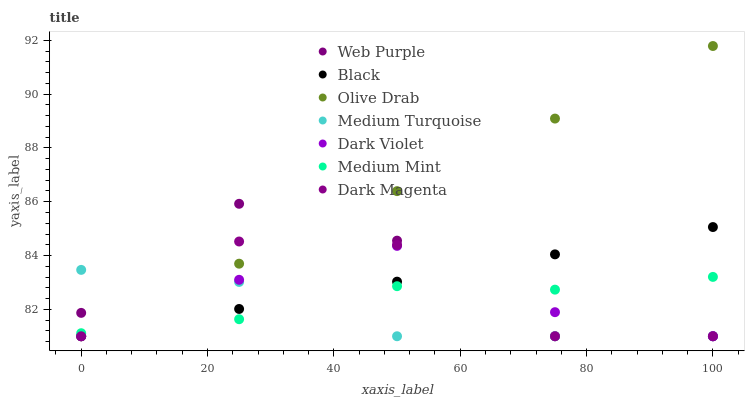Does Medium Turquoise have the minimum area under the curve?
Answer yes or no. Yes. Does Olive Drab have the maximum area under the curve?
Answer yes or no. Yes. Does Dark Magenta have the minimum area under the curve?
Answer yes or no. No. Does Dark Magenta have the maximum area under the curve?
Answer yes or no. No. Is Olive Drab the smoothest?
Answer yes or no. Yes. Is Web Purple the roughest?
Answer yes or no. Yes. Is Dark Magenta the smoothest?
Answer yes or no. No. Is Dark Magenta the roughest?
Answer yes or no. No. Does Dark Magenta have the lowest value?
Answer yes or no. Yes. Does Olive Drab have the highest value?
Answer yes or no. Yes. Does Dark Magenta have the highest value?
Answer yes or no. No. Does Dark Violet intersect Black?
Answer yes or no. Yes. Is Dark Violet less than Black?
Answer yes or no. No. Is Dark Violet greater than Black?
Answer yes or no. No. 